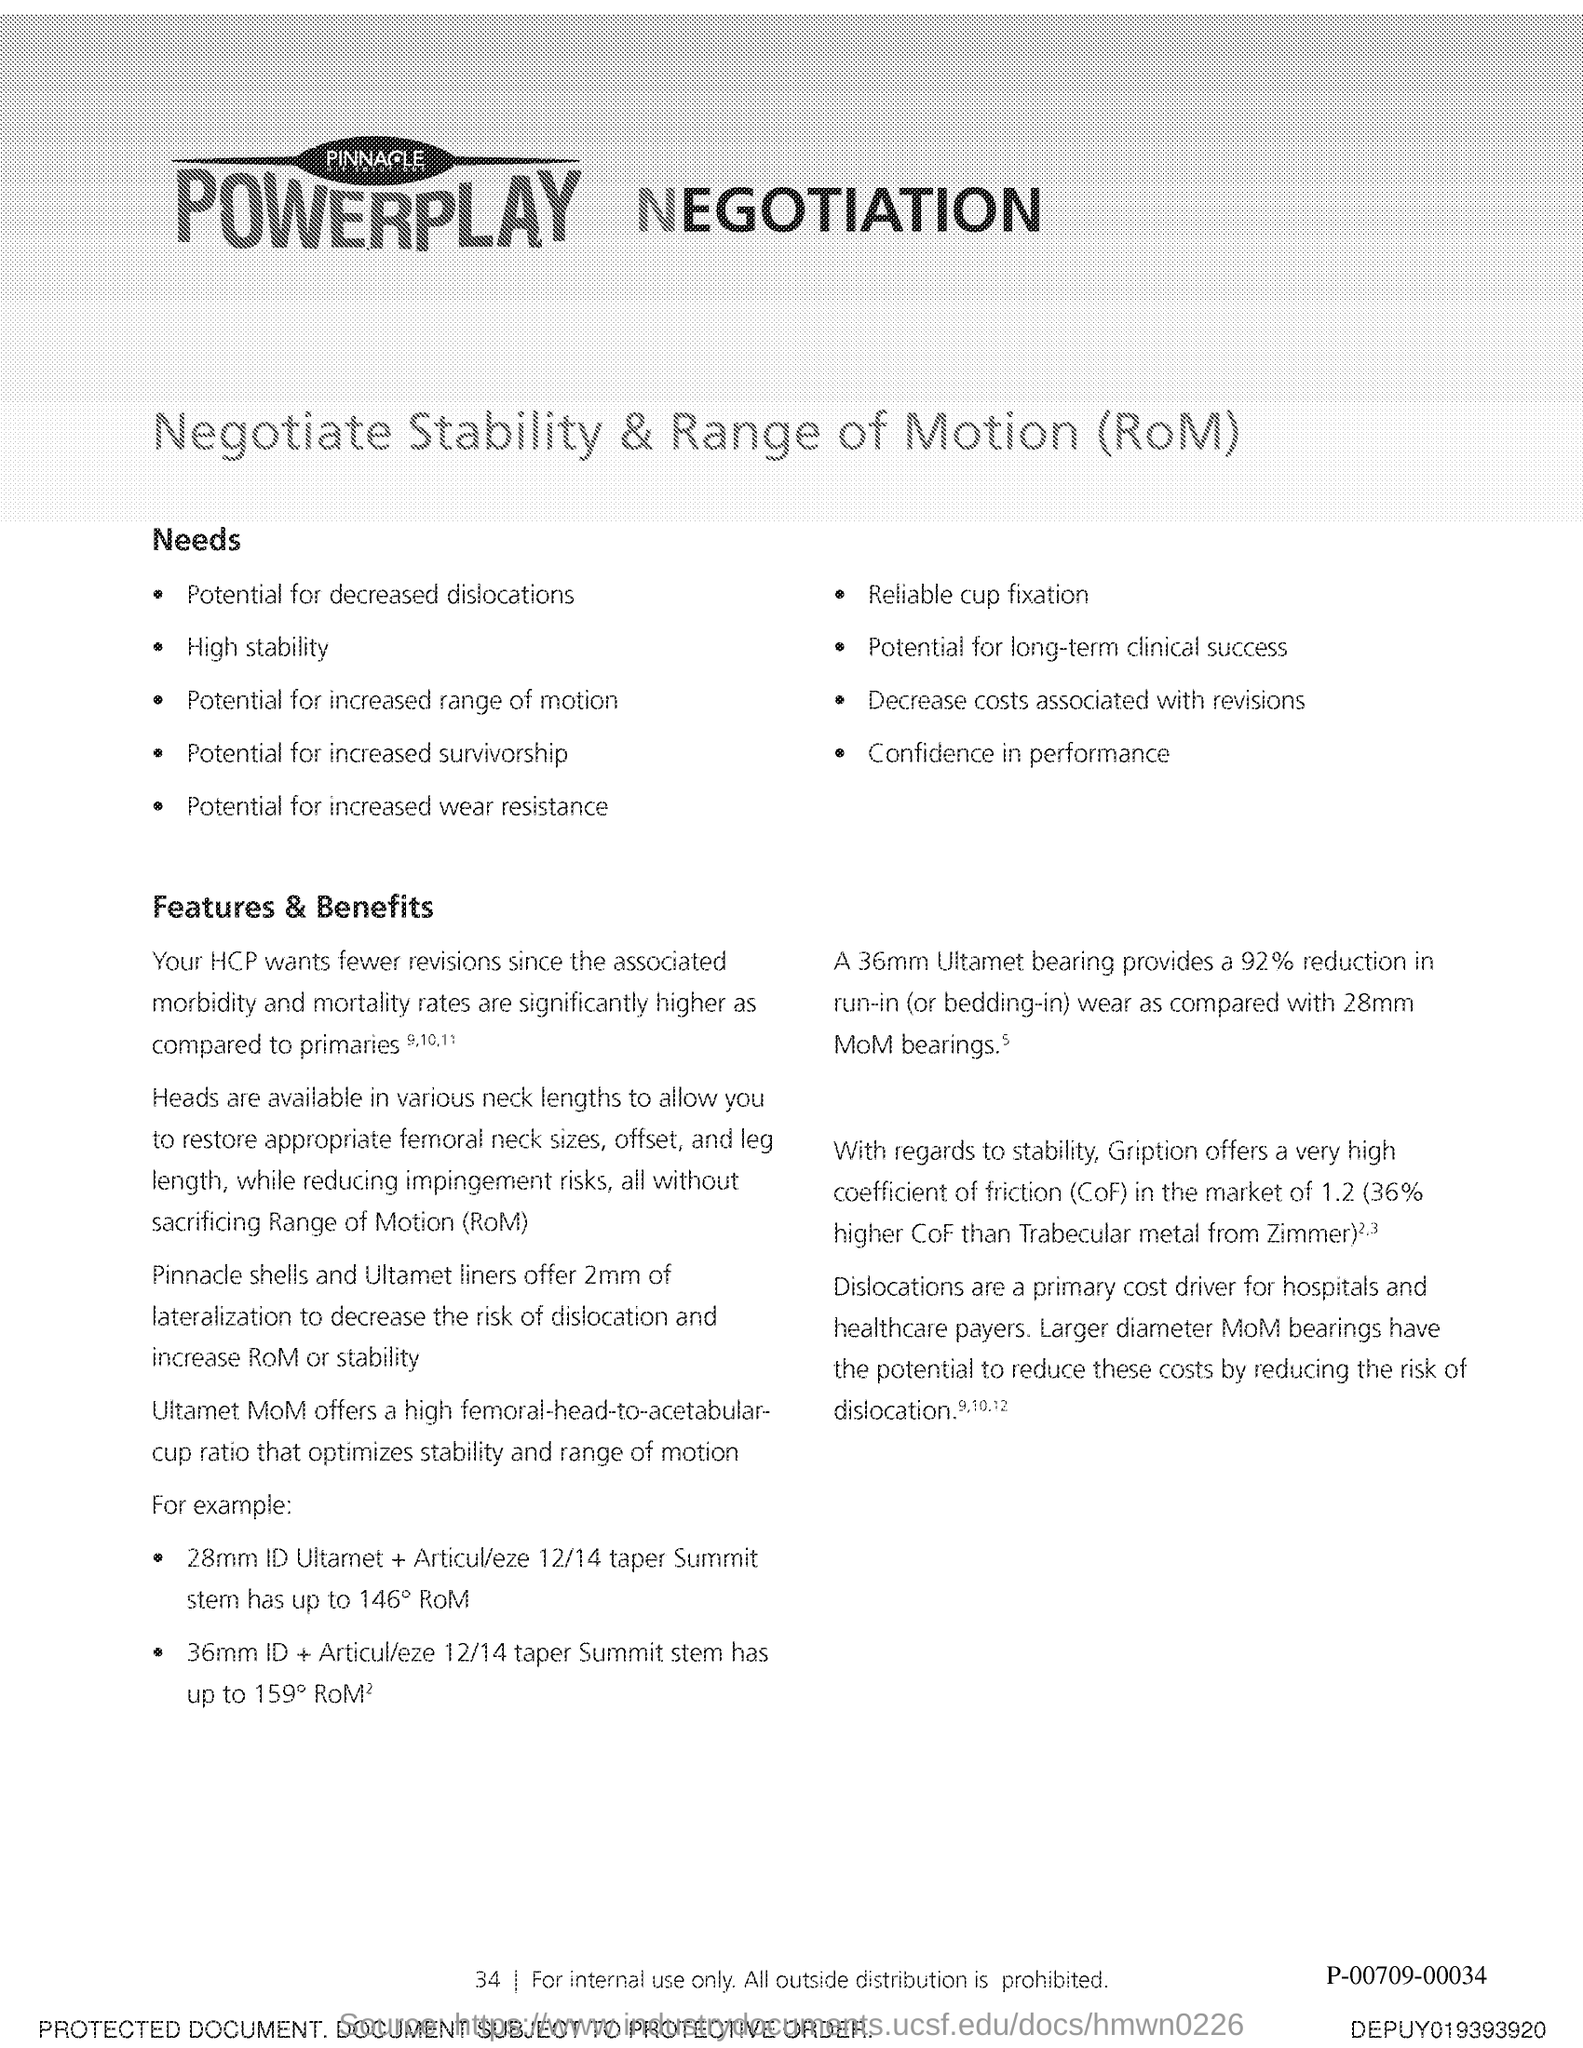What does rom stands for ?
Your response must be concise. Range of Motion. What does cof stands for ?
Your response must be concise. Coefficient of friction. 